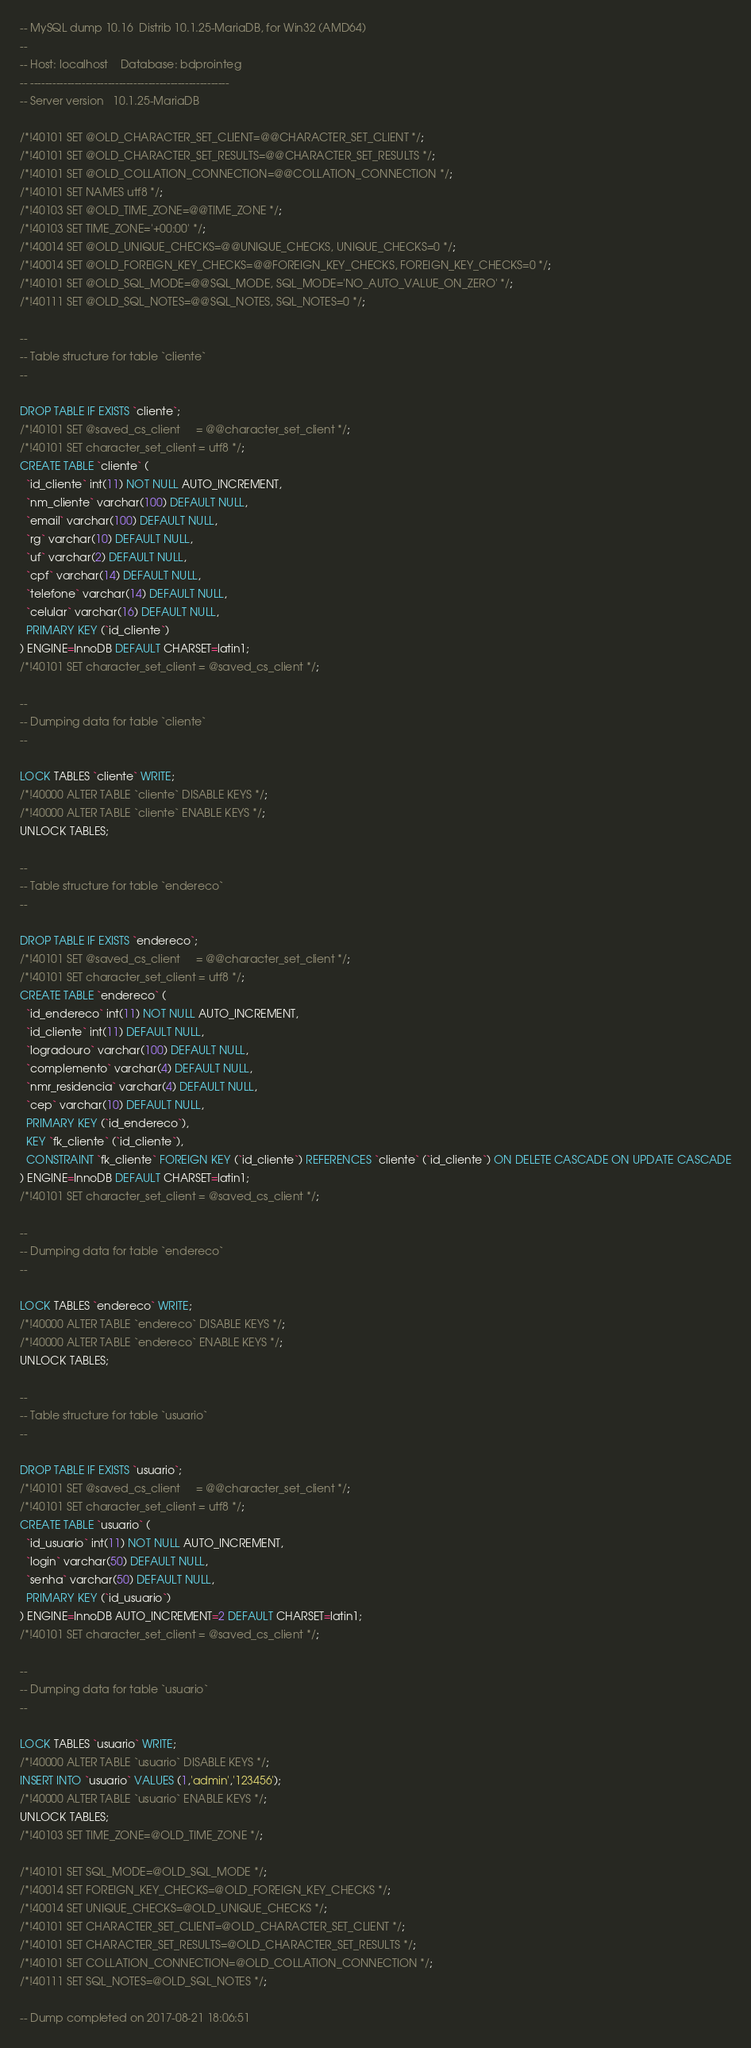Convert code to text. <code><loc_0><loc_0><loc_500><loc_500><_SQL_>-- MySQL dump 10.16  Distrib 10.1.25-MariaDB, for Win32 (AMD64)
--
-- Host: localhost    Database: bdprointeg
-- ------------------------------------------------------
-- Server version	10.1.25-MariaDB

/*!40101 SET @OLD_CHARACTER_SET_CLIENT=@@CHARACTER_SET_CLIENT */;
/*!40101 SET @OLD_CHARACTER_SET_RESULTS=@@CHARACTER_SET_RESULTS */;
/*!40101 SET @OLD_COLLATION_CONNECTION=@@COLLATION_CONNECTION */;
/*!40101 SET NAMES utf8 */;
/*!40103 SET @OLD_TIME_ZONE=@@TIME_ZONE */;
/*!40103 SET TIME_ZONE='+00:00' */;
/*!40014 SET @OLD_UNIQUE_CHECKS=@@UNIQUE_CHECKS, UNIQUE_CHECKS=0 */;
/*!40014 SET @OLD_FOREIGN_KEY_CHECKS=@@FOREIGN_KEY_CHECKS, FOREIGN_KEY_CHECKS=0 */;
/*!40101 SET @OLD_SQL_MODE=@@SQL_MODE, SQL_MODE='NO_AUTO_VALUE_ON_ZERO' */;
/*!40111 SET @OLD_SQL_NOTES=@@SQL_NOTES, SQL_NOTES=0 */;

--
-- Table structure for table `cliente`
--

DROP TABLE IF EXISTS `cliente`;
/*!40101 SET @saved_cs_client     = @@character_set_client */;
/*!40101 SET character_set_client = utf8 */;
CREATE TABLE `cliente` (
  `id_cliente` int(11) NOT NULL AUTO_INCREMENT,
  `nm_cliente` varchar(100) DEFAULT NULL,
  `email` varchar(100) DEFAULT NULL,
  `rg` varchar(10) DEFAULT NULL,
  `uf` varchar(2) DEFAULT NULL,
  `cpf` varchar(14) DEFAULT NULL,
  `telefone` varchar(14) DEFAULT NULL,
  `celular` varchar(16) DEFAULT NULL,
  PRIMARY KEY (`id_cliente`)
) ENGINE=InnoDB DEFAULT CHARSET=latin1;
/*!40101 SET character_set_client = @saved_cs_client */;

--
-- Dumping data for table `cliente`
--

LOCK TABLES `cliente` WRITE;
/*!40000 ALTER TABLE `cliente` DISABLE KEYS */;
/*!40000 ALTER TABLE `cliente` ENABLE KEYS */;
UNLOCK TABLES;

--
-- Table structure for table `endereco`
--

DROP TABLE IF EXISTS `endereco`;
/*!40101 SET @saved_cs_client     = @@character_set_client */;
/*!40101 SET character_set_client = utf8 */;
CREATE TABLE `endereco` (
  `id_endereco` int(11) NOT NULL AUTO_INCREMENT,
  `id_cliente` int(11) DEFAULT NULL,
  `logradouro` varchar(100) DEFAULT NULL,
  `complemento` varchar(4) DEFAULT NULL,
  `nmr_residencia` varchar(4) DEFAULT NULL,
  `cep` varchar(10) DEFAULT NULL,
  PRIMARY KEY (`id_endereco`),
  KEY `fk_cliente` (`id_cliente`),
  CONSTRAINT `fk_cliente` FOREIGN KEY (`id_cliente`) REFERENCES `cliente` (`id_cliente`) ON DELETE CASCADE ON UPDATE CASCADE
) ENGINE=InnoDB DEFAULT CHARSET=latin1;
/*!40101 SET character_set_client = @saved_cs_client */;

--
-- Dumping data for table `endereco`
--

LOCK TABLES `endereco` WRITE;
/*!40000 ALTER TABLE `endereco` DISABLE KEYS */;
/*!40000 ALTER TABLE `endereco` ENABLE KEYS */;
UNLOCK TABLES;

--
-- Table structure for table `usuario`
--

DROP TABLE IF EXISTS `usuario`;
/*!40101 SET @saved_cs_client     = @@character_set_client */;
/*!40101 SET character_set_client = utf8 */;
CREATE TABLE `usuario` (
  `id_usuario` int(11) NOT NULL AUTO_INCREMENT,
  `login` varchar(50) DEFAULT NULL,
  `senha` varchar(50) DEFAULT NULL,
  PRIMARY KEY (`id_usuario`)
) ENGINE=InnoDB AUTO_INCREMENT=2 DEFAULT CHARSET=latin1;
/*!40101 SET character_set_client = @saved_cs_client */;

--
-- Dumping data for table `usuario`
--

LOCK TABLES `usuario` WRITE;
/*!40000 ALTER TABLE `usuario` DISABLE KEYS */;
INSERT INTO `usuario` VALUES (1,'admin','123456');
/*!40000 ALTER TABLE `usuario` ENABLE KEYS */;
UNLOCK TABLES;
/*!40103 SET TIME_ZONE=@OLD_TIME_ZONE */;

/*!40101 SET SQL_MODE=@OLD_SQL_MODE */;
/*!40014 SET FOREIGN_KEY_CHECKS=@OLD_FOREIGN_KEY_CHECKS */;
/*!40014 SET UNIQUE_CHECKS=@OLD_UNIQUE_CHECKS */;
/*!40101 SET CHARACTER_SET_CLIENT=@OLD_CHARACTER_SET_CLIENT */;
/*!40101 SET CHARACTER_SET_RESULTS=@OLD_CHARACTER_SET_RESULTS */;
/*!40101 SET COLLATION_CONNECTION=@OLD_COLLATION_CONNECTION */;
/*!40111 SET SQL_NOTES=@OLD_SQL_NOTES */;

-- Dump completed on 2017-08-21 18:06:51
</code> 